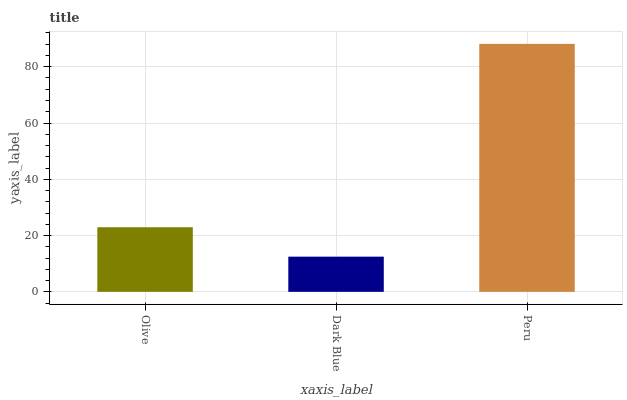Is Peru the minimum?
Answer yes or no. No. Is Dark Blue the maximum?
Answer yes or no. No. Is Peru greater than Dark Blue?
Answer yes or no. Yes. Is Dark Blue less than Peru?
Answer yes or no. Yes. Is Dark Blue greater than Peru?
Answer yes or no. No. Is Peru less than Dark Blue?
Answer yes or no. No. Is Olive the high median?
Answer yes or no. Yes. Is Olive the low median?
Answer yes or no. Yes. Is Peru the high median?
Answer yes or no. No. Is Peru the low median?
Answer yes or no. No. 